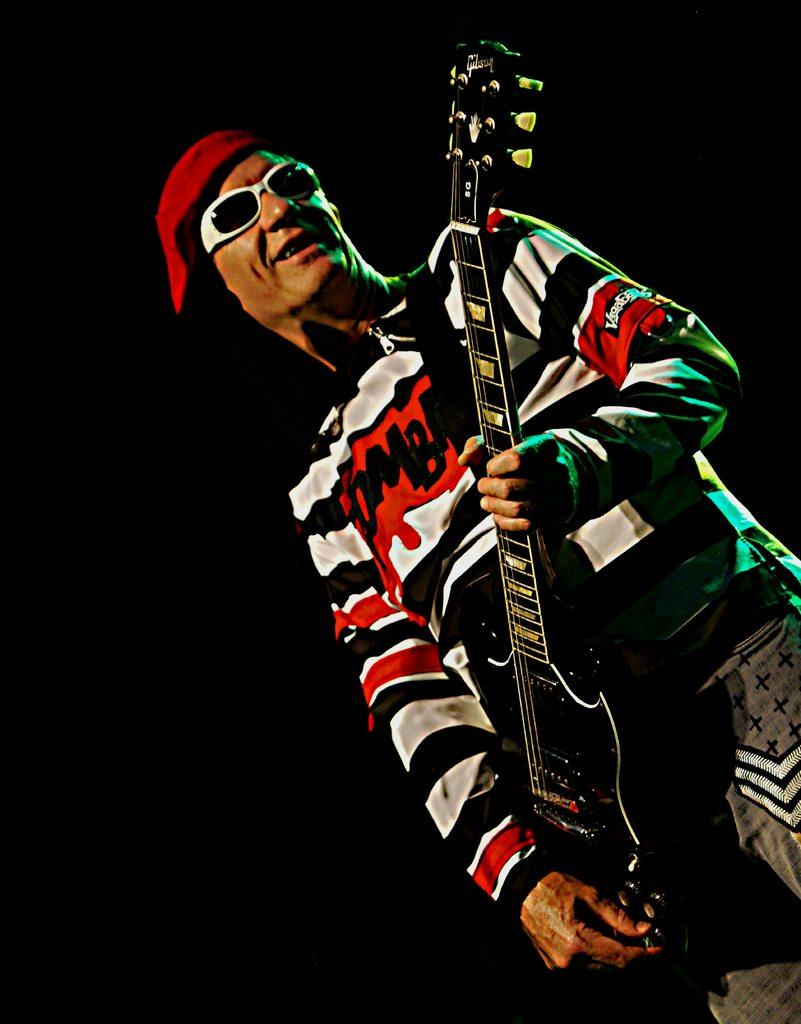What is the main subject of the image? The main subject of the image is a man. What is the man doing in the image? The man is standing in the image. What object is the man holding in the image? The man is holding a guitar in the image. Can you describe the man's clothing in the image? The man is wearing a T-shirt, a cap, goggles, and trousers in the image. What can be observed about the background of the image? The background of the image is dark. What type of pin can be seen on the man's shirt in the image? There is no pin visible on the man's shirt in the image. What kind of club is the man holding in the image? The man is not holding a club in the image; he is holding a guitar. 